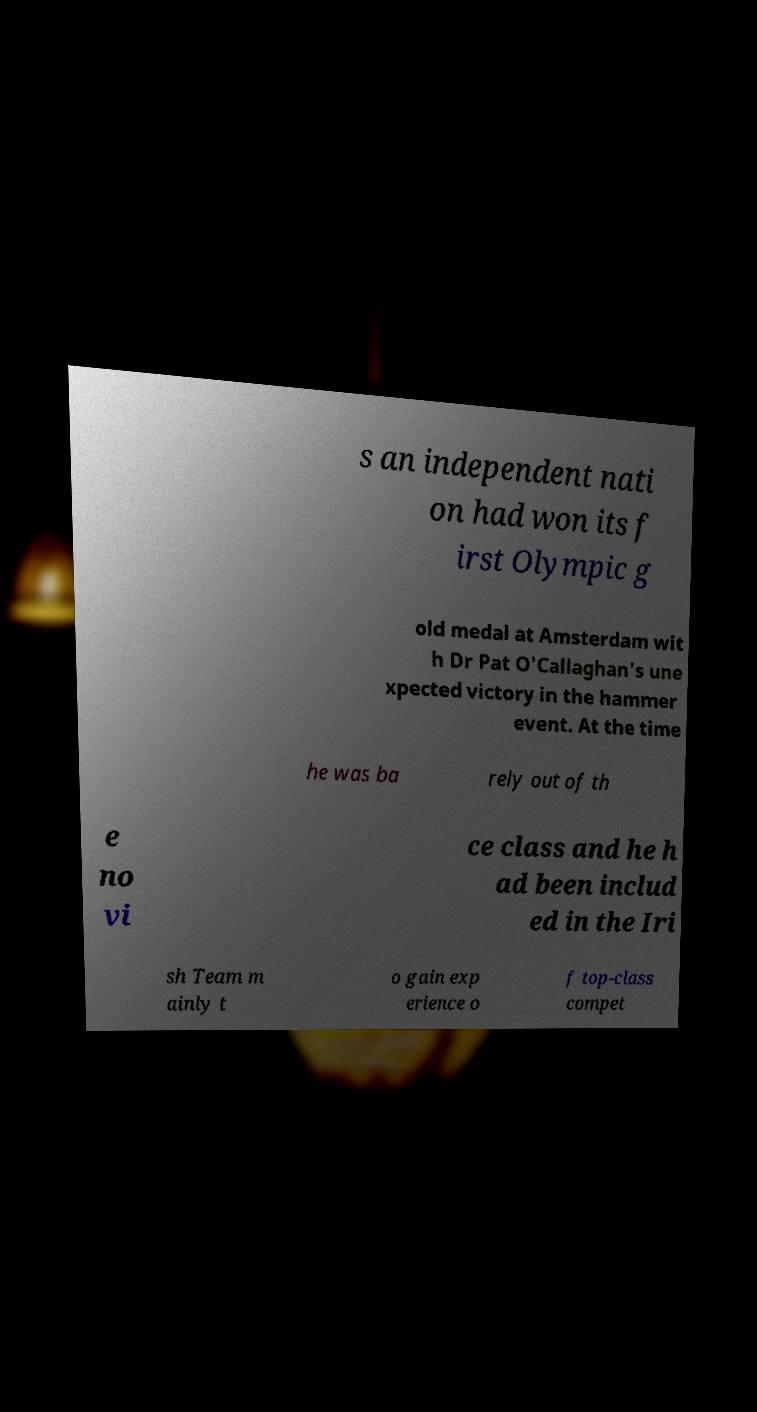Can you accurately transcribe the text from the provided image for me? s an independent nati on had won its f irst Olympic g old medal at Amsterdam wit h Dr Pat O'Callaghan's une xpected victory in the hammer event. At the time he was ba rely out of th e no vi ce class and he h ad been includ ed in the Iri sh Team m ainly t o gain exp erience o f top-class compet 